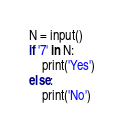Convert code to text. <code><loc_0><loc_0><loc_500><loc_500><_Python_>N = input()
if '7' in N:
    print('Yes')
else:
    print('No')</code> 